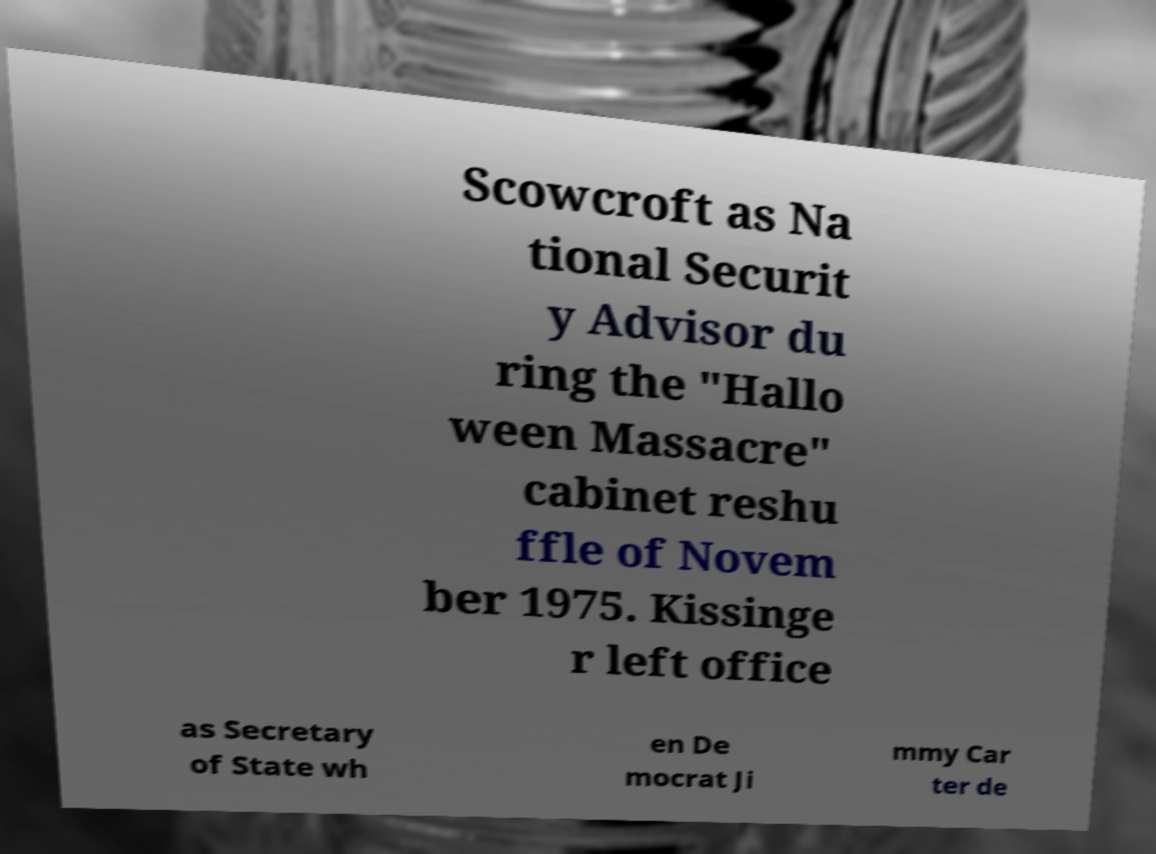Can you accurately transcribe the text from the provided image for me? Scowcroft as Na tional Securit y Advisor du ring the "Hallo ween Massacre" cabinet reshu ffle of Novem ber 1975. Kissinge r left office as Secretary of State wh en De mocrat Ji mmy Car ter de 